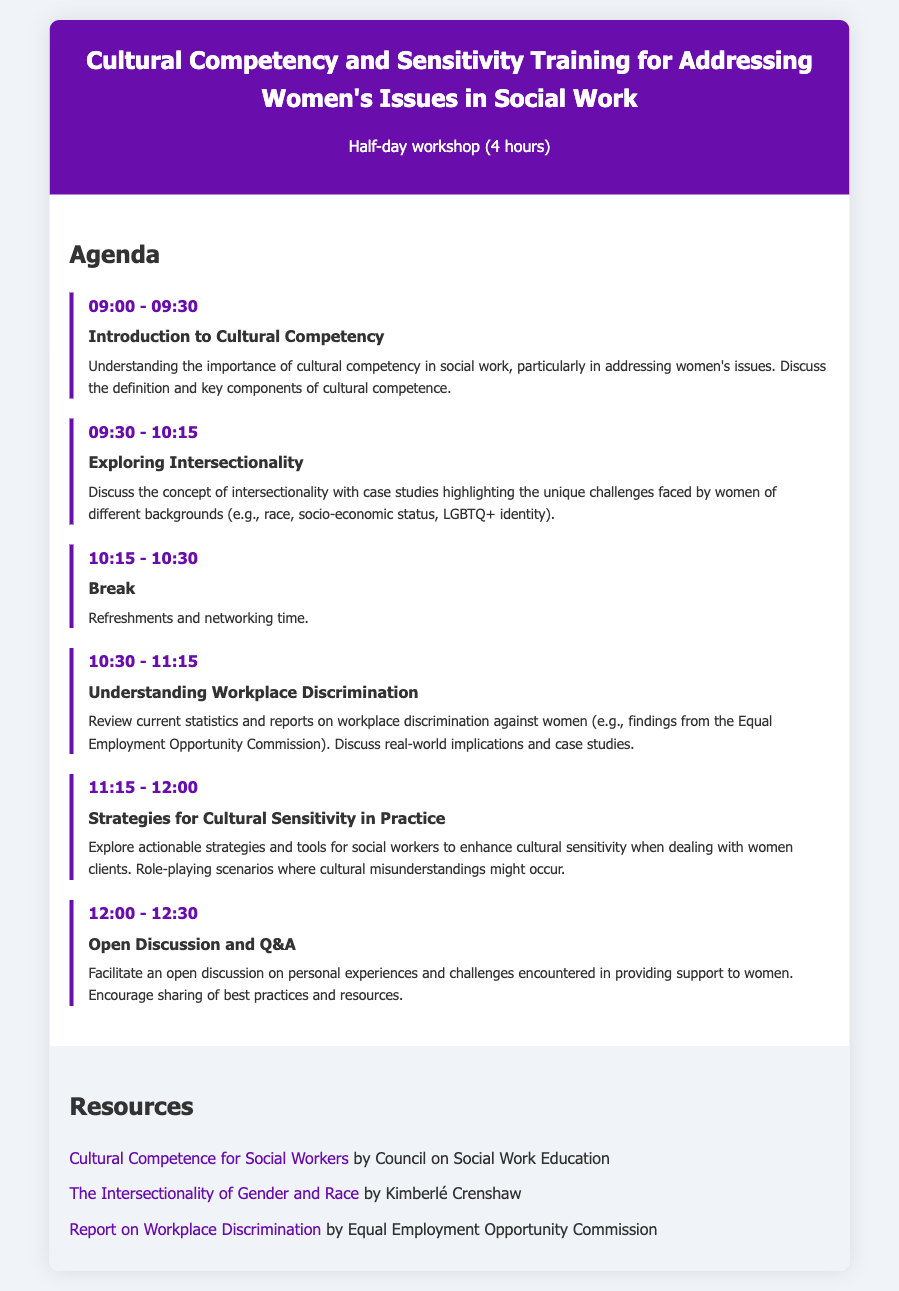what is the total duration of the training session? The total duration is specified as a half-day workshop lasting 4 hours.
Answer: 4 hours what time does the session start? The agenda indicates that the training session starts at 09:00.
Answer: 09:00 what is the focus of the activity at 10:30? The activity scheduled for 10:30 is "Understanding Workplace Discrimination," which focuses on reviews and discussions related to workplace discrimination against women.
Answer: Understanding Workplace Discrimination who is the author of the resource "The Intersectionality of Gender and Race"? This document lists Kimberlé Crenshaw as the author of the referenced resource on intersectionality.
Answer: Kimberlé Crenshaw what is the title of the first activity? The title of the first activity is "Introduction to Cultural Competency."
Answer: Introduction to Cultural Competency how long is the break scheduled for? The break is from 10:15 to 10:30, which means it is scheduled for 15 minutes.
Answer: 15 minutes what is emphasized in the last agenda item? The last agenda item emphasizes an "Open Discussion and Q&A," allowing participants to share experiences and challenges.
Answer: Open Discussion and Q&A what is one strategy mentioned for practitioners to enhance sensitivity? The agenda mentions exploring actionable strategies and tools, specifically via role-playing scenarios, to enhance cultural sensitivity.
Answer: Role-playing scenarios 